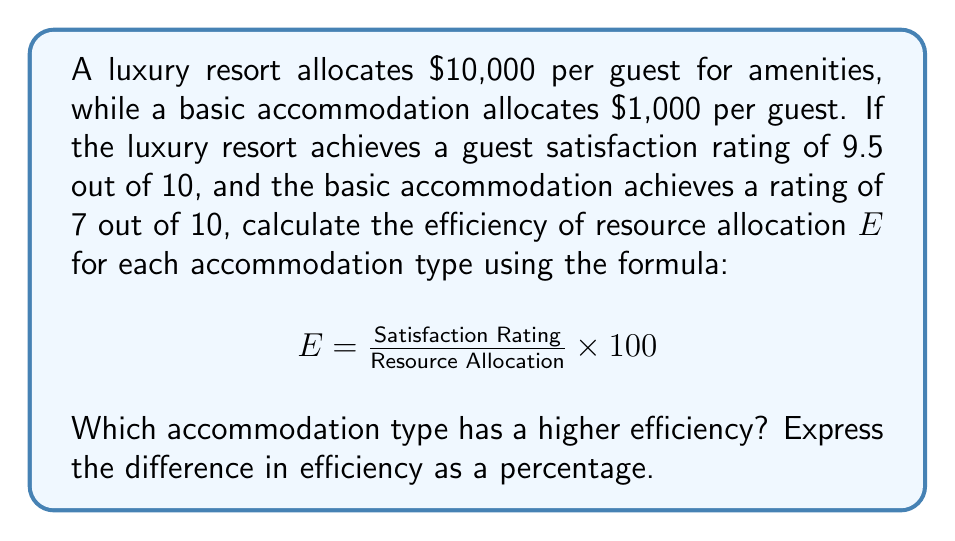Show me your answer to this math problem. 1. Calculate efficiency for luxury resort:
   $$E_{\text{luxury}} = \frac{9.5}{10000} \times 100 = 0.095\%$$

2. Calculate efficiency for basic accommodation:
   $$E_{\text{basic}} = \frac{7}{1000} \times 100 = 0.7\%$$

3. Compare efficiencies:
   The basic accommodation has a higher efficiency.

4. Calculate the difference in efficiency:
   $$\text{Difference} = E_{\text{basic}} - E_{\text{luxury}} = 0.7\% - 0.095\% = 0.605\%$$

5. Express the difference as a percentage of the luxury resort's efficiency:
   $$\text{Percentage difference} = \frac{0.605\%}{0.095\%} \times 100 = 636.84\%$$
Answer: Basic accommodation; 636.84% higher efficiency 